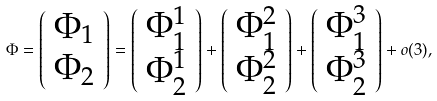Convert formula to latex. <formula><loc_0><loc_0><loc_500><loc_500>\Phi = \left ( \begin{array} { c } \Phi _ { 1 } \\ \Phi _ { 2 } \end{array} \right ) = \left ( \begin{array} { c } \Phi ^ { 1 } _ { 1 } \\ \Phi ^ { 1 } _ { 2 } \end{array} \right ) + \left ( \begin{array} { c } \Phi ^ { 2 } _ { 1 } \\ \Phi ^ { 2 } _ { 2 } \end{array} \right ) + \left ( \begin{array} { c } \Phi ^ { 3 } _ { 1 } \\ \Phi ^ { 3 } _ { 2 } \end{array} \right ) + o ( 3 ) ,</formula> 